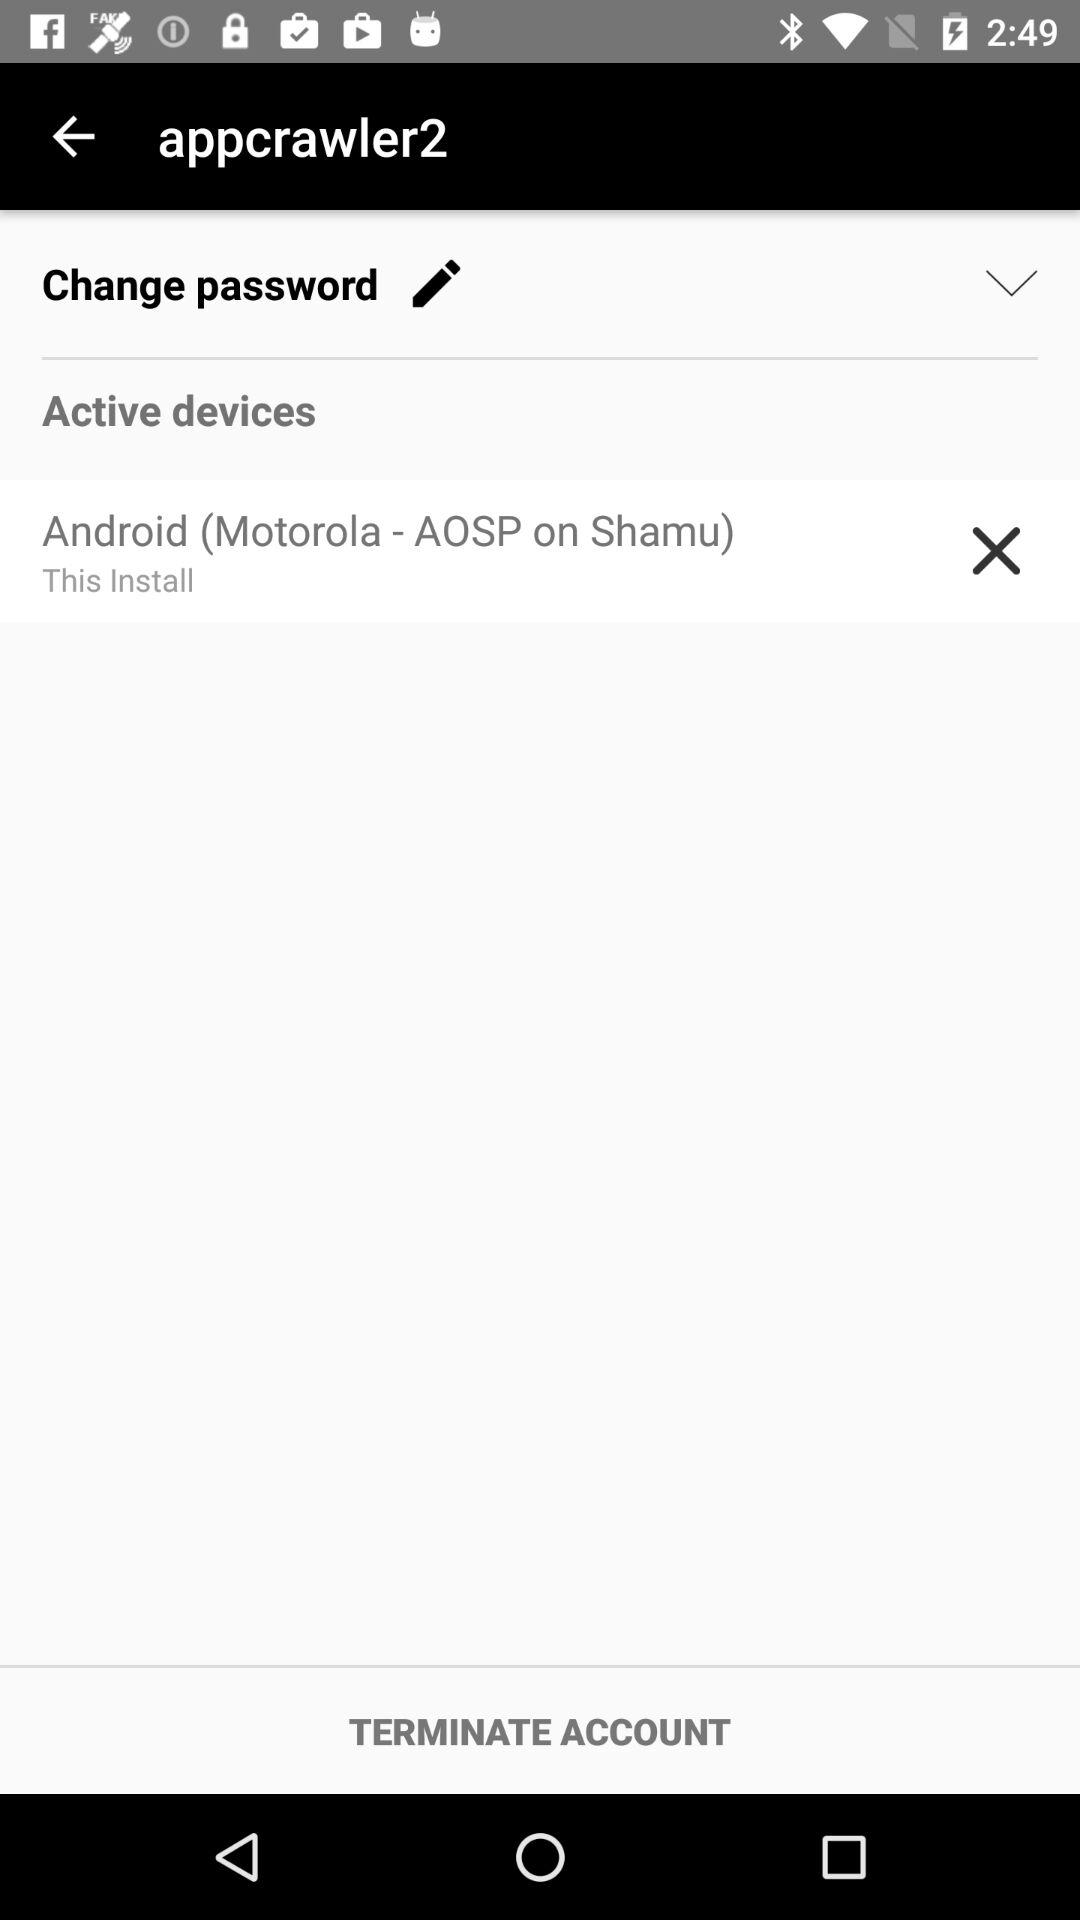Has the password been changed?
When the provided information is insufficient, respond with <no answer>. <no answer> 